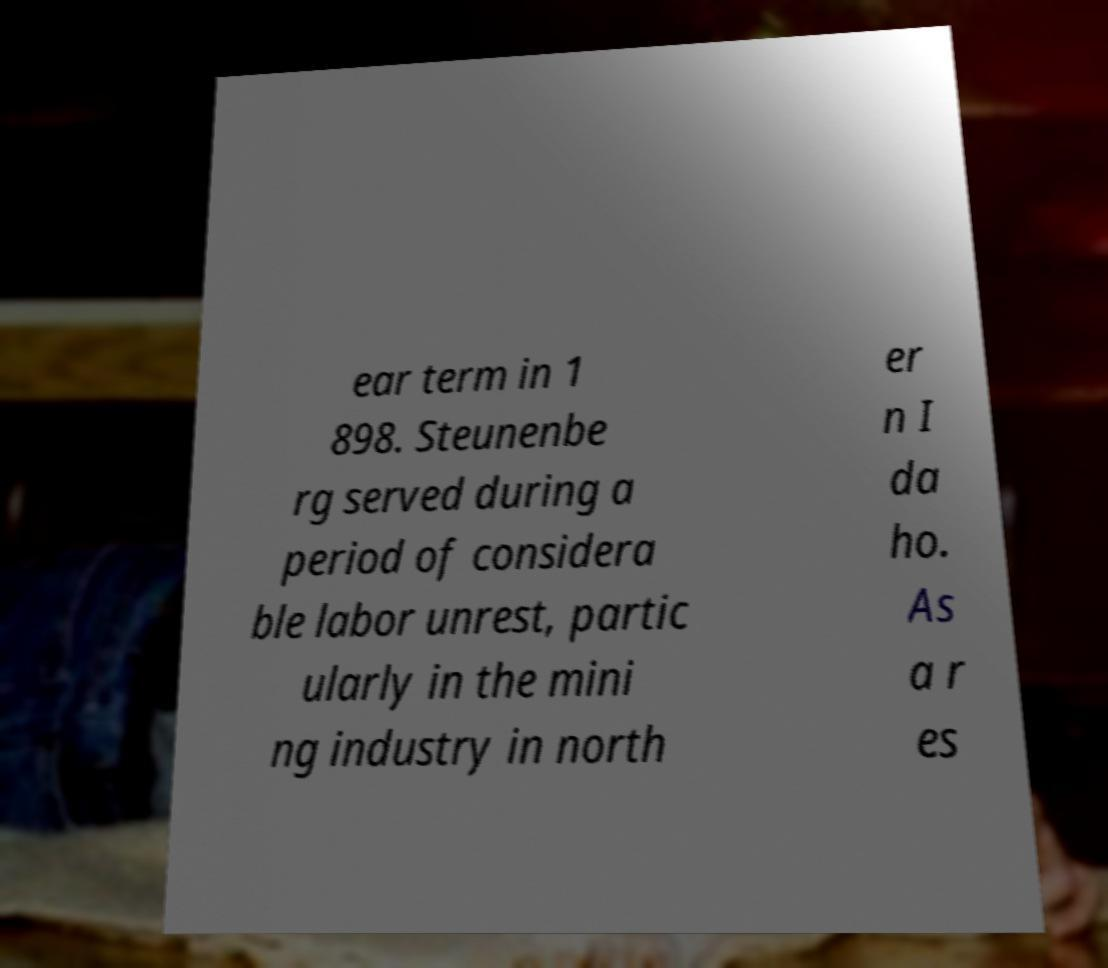Can you accurately transcribe the text from the provided image for me? ear term in 1 898. Steunenbe rg served during a period of considera ble labor unrest, partic ularly in the mini ng industry in north er n I da ho. As a r es 